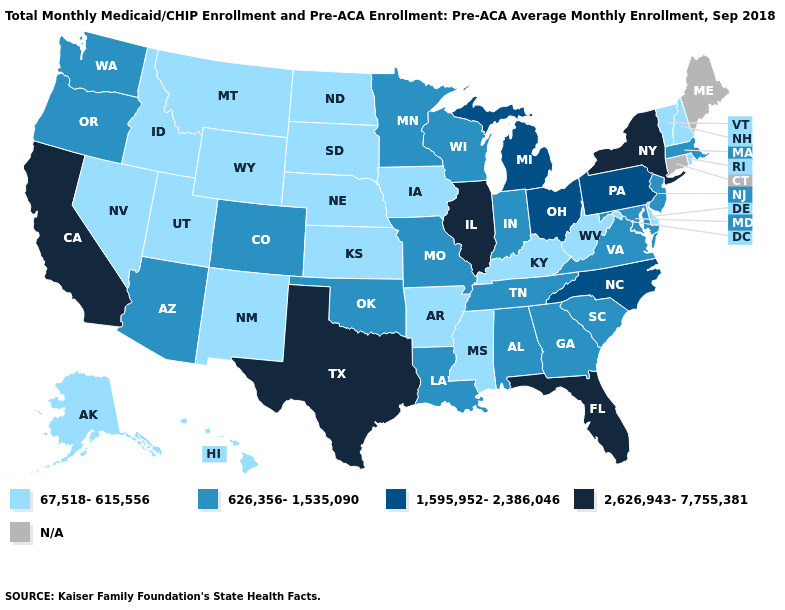What is the lowest value in the MidWest?
Be succinct. 67,518-615,556. Name the states that have a value in the range N/A?
Concise answer only. Connecticut, Maine. Which states have the highest value in the USA?
Answer briefly. California, Florida, Illinois, New York, Texas. Name the states that have a value in the range 67,518-615,556?
Quick response, please. Alaska, Arkansas, Delaware, Hawaii, Idaho, Iowa, Kansas, Kentucky, Mississippi, Montana, Nebraska, Nevada, New Hampshire, New Mexico, North Dakota, Rhode Island, South Dakota, Utah, Vermont, West Virginia, Wyoming. Which states have the lowest value in the MidWest?
Short answer required. Iowa, Kansas, Nebraska, North Dakota, South Dakota. Which states hav the highest value in the South?
Concise answer only. Florida, Texas. Is the legend a continuous bar?
Short answer required. No. Name the states that have a value in the range 1,595,952-2,386,046?
Short answer required. Michigan, North Carolina, Ohio, Pennsylvania. What is the value of Georgia?
Give a very brief answer. 626,356-1,535,090. Name the states that have a value in the range 67,518-615,556?
Be succinct. Alaska, Arkansas, Delaware, Hawaii, Idaho, Iowa, Kansas, Kentucky, Mississippi, Montana, Nebraska, Nevada, New Hampshire, New Mexico, North Dakota, Rhode Island, South Dakota, Utah, Vermont, West Virginia, Wyoming. What is the value of South Dakota?
Concise answer only. 67,518-615,556. Name the states that have a value in the range 2,626,943-7,755,381?
Give a very brief answer. California, Florida, Illinois, New York, Texas. Among the states that border Oklahoma , does New Mexico have the highest value?
Answer briefly. No. Which states have the highest value in the USA?
Be succinct. California, Florida, Illinois, New York, Texas. 